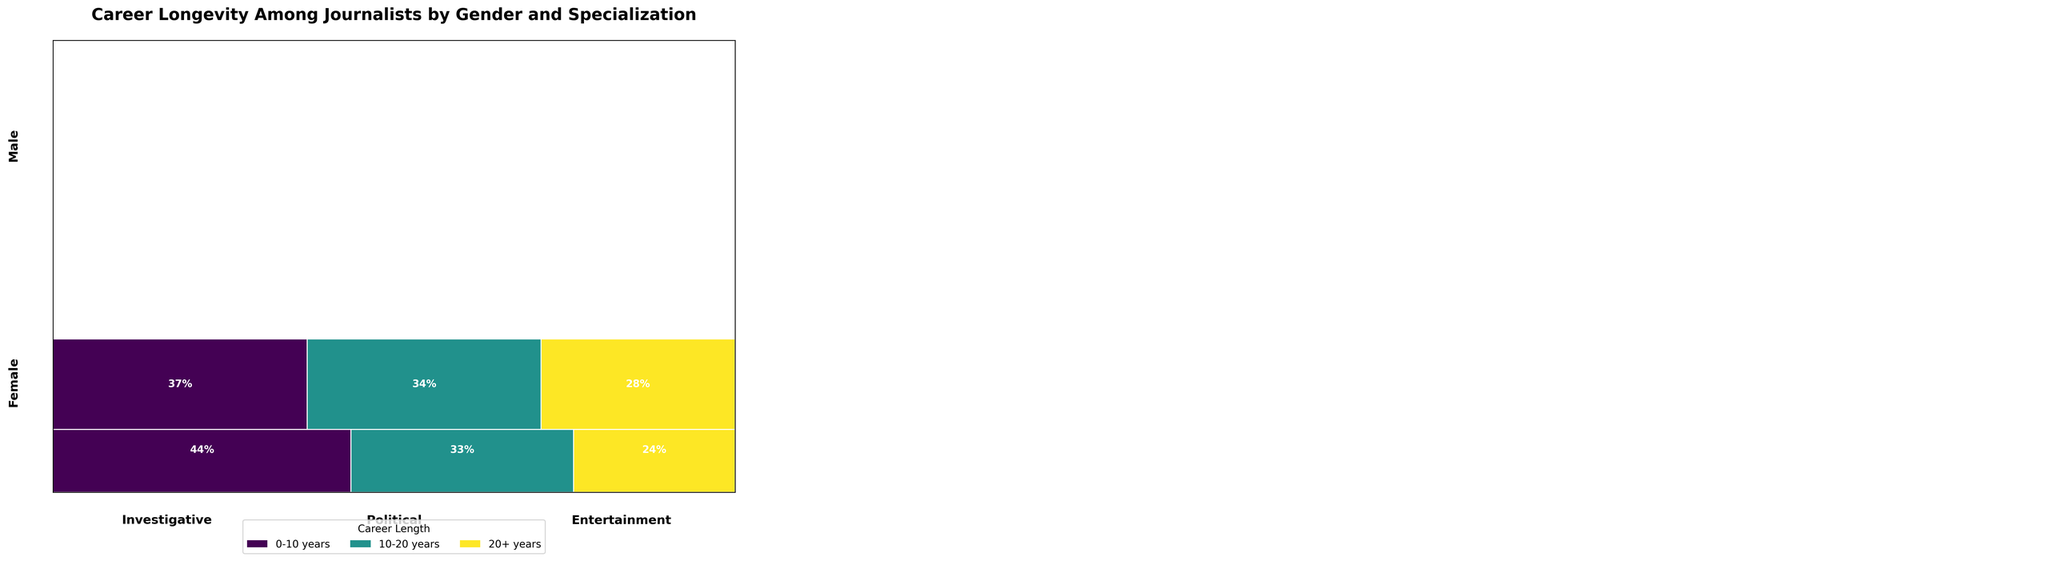What's the title of the plot? The title is usually located at the top center of the plot and provides a brief description of what the plot represents.
Answer: Career Longevity Among Journalists by Gender and Specialization Which specialization has the smallest proportion of journalists with 20+ years career length among females? Locate the female journalists' section and compare the widths of the 20+ years segments in Investigative, Political, and Entertainment categories. Entertainment has the narrowest segment.
Answer: Entertainment Between male and female journalists in the Investigative category, who has a higher count of journalists with a career length of 20+ years? Identify the 20+ years career length segments within the Investigative category for both genders and compare their heights.
Answer: Male In the Political specialization, which gender has a higher proportion of journalists with 10-20 years of experience? Look at the 10-20 years segments within the Political category for both genders and compare their widths.
Answer: Male What is the combined proportion of female journalists with 0-10 years and 10-20 years of experience in the Investigative category? Sum the widths of the 0-10 years and 10-20 years career segments within the Investigative category for females. The sum of these proportions gives the combined proportion.
Answer: 83/(83+62+45) + 62/(83+62+45) ≈ 0.55 + 0.28 ≈ 0.83 or 83% Which specialization has the highest proportion of males with 20+ years of career length? Among the male journalists, compare the widths of the 20+ years segments in Investigative, Political, and Entertainment categories.
Answer: Investigative Do female or male journalists dominate the Entertainment specialization in terms of the total count? Compare the total heights of the Entertainment segments for both genders.
Answer: Female What is the total number of male journalists in the Political specialization? Sum the heights of all segments within the Political category for male journalists.
Answer: 52 + 63 + 68 = 183 In Investigative specialization, is there an equal gender distribution for journalists with 10-20 years of experience? Compare the heights of the 10-20 years segments for both genders in the Investigative category.
Answer: No Which gender has a higher proportion of journalists with 0-10 years experience across all specializations? Sum the widths of the 0-10 years segments for all specializations separately for both genders and compare them.
Answer: Female 